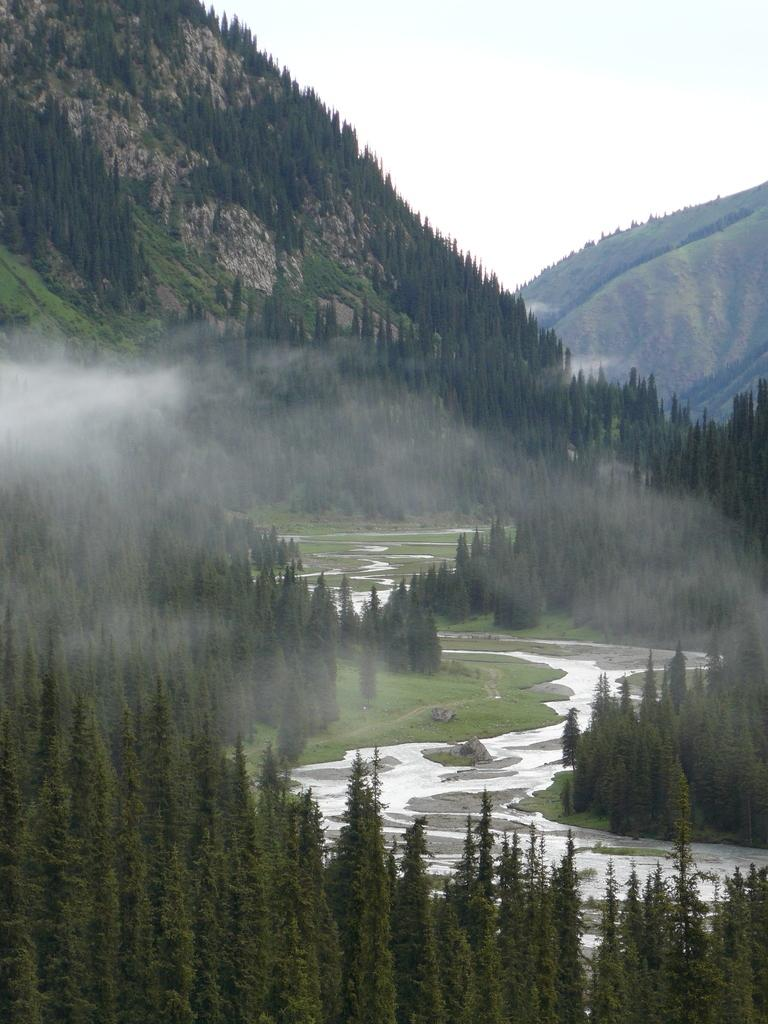What natural element can be seen in the image? Water is visible in the image. What type of vegetation is present in the image? There is grass and trees in the image. What geographical feature is in the background of the image? There is a mountain in the image. What part of the natural environment is visible in the image? The sky is visible in the image. What type of corn can be seen growing on the mountain in the image? There is no corn visible in the image, and the mountain does not appear to have any vegetation growing on it. 